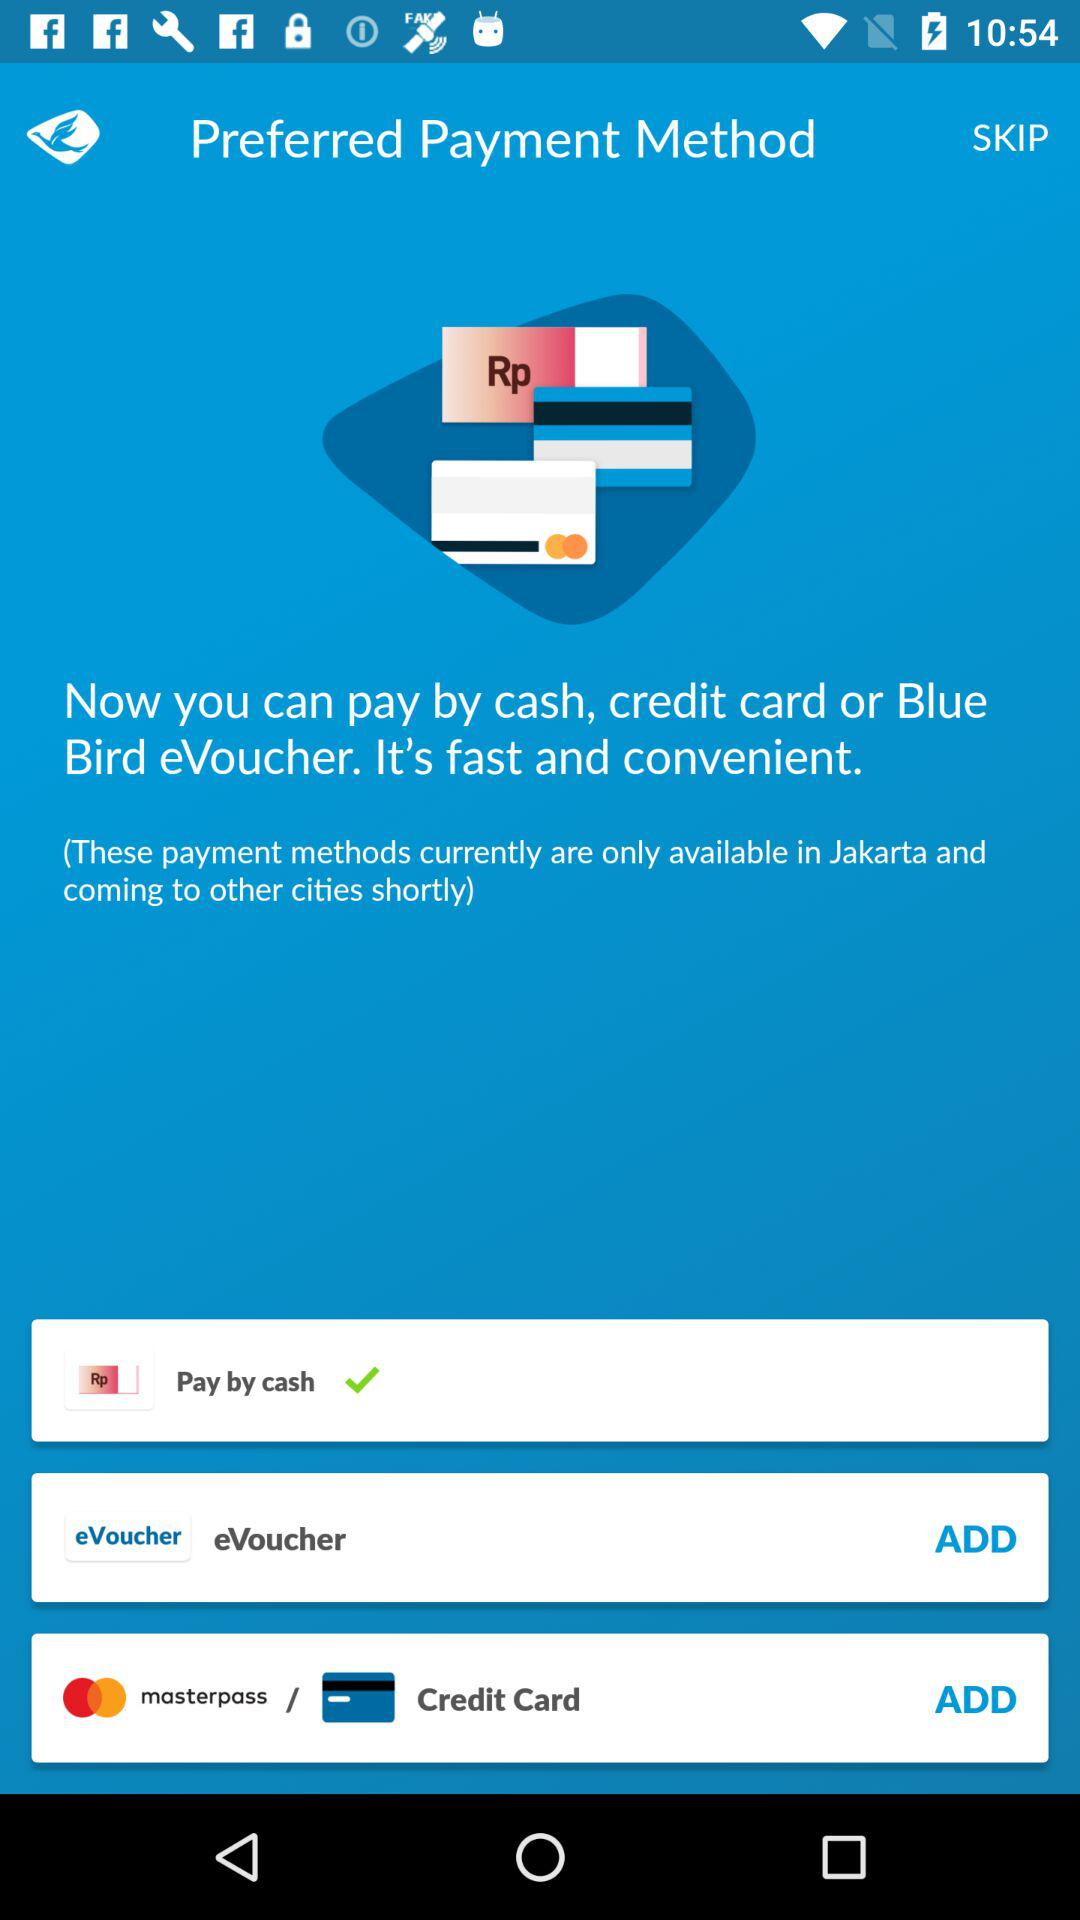What is the selected method of payment? The selected method is "Pay by cash". 